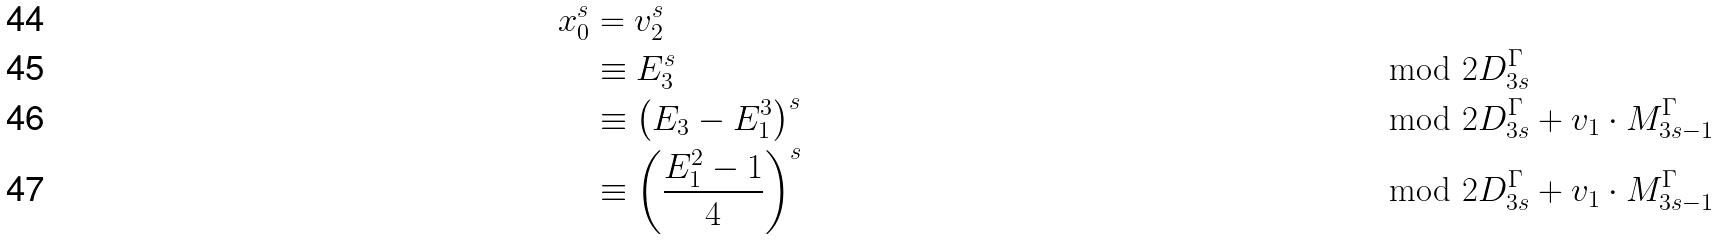<formula> <loc_0><loc_0><loc_500><loc_500>x _ { 0 } ^ { s } & = v _ { 2 } ^ { s } \\ & \equiv E _ { 3 } ^ { s } & & \mod 2 D ^ { \Gamma } _ { 3 s } \\ & \equiv \left ( E _ { 3 } - E _ { 1 } ^ { 3 } \right ) ^ { s } & & \mod 2 D ^ { \Gamma } _ { 3 s } + v _ { 1 } \cdot M ^ { \Gamma } _ { 3 s - 1 } \\ & \equiv \left ( \frac { E _ { 1 } ^ { 2 } - 1 } { 4 } \right ) ^ { s } & & \mod 2 D ^ { \Gamma } _ { 3 s } + v _ { 1 } \cdot M ^ { \Gamma } _ { 3 s - 1 }</formula> 